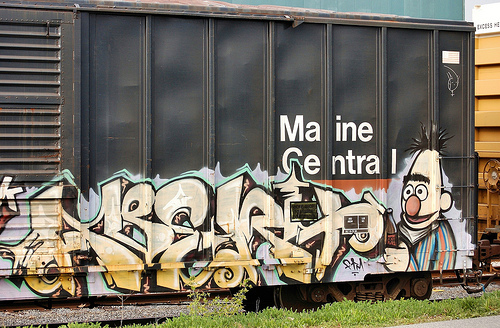<image>
Is there a container on the grass? No. The container is not positioned on the grass. They may be near each other, but the container is not supported by or resting on top of the grass. Is there a bert in front of the train car? Yes. The bert is positioned in front of the train car, appearing closer to the camera viewpoint. 